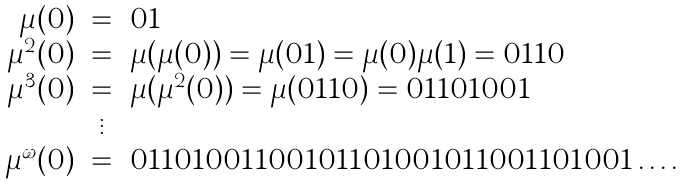<formula> <loc_0><loc_0><loc_500><loc_500>\begin{array} { r c l } \mu ( 0 ) & = & 0 1 \\ \mu ^ { 2 } ( 0 ) & = & \mu ( \mu ( 0 ) ) = \mu ( 0 1 ) = \mu ( 0 ) \mu ( 1 ) = 0 1 1 0 \\ \mu ^ { 3 } ( 0 ) & = & \mu ( \mu ^ { 2 } ( 0 ) ) = \mu ( 0 1 1 0 ) = 0 1 1 0 1 0 0 1 \\ & \vdots & \\ \mu ^ { \omega } ( 0 ) & = & 0 1 1 0 1 0 0 1 1 0 0 1 0 1 1 0 1 0 0 1 0 1 1 0 0 1 1 0 1 0 0 1 \dots . \end{array}</formula> 